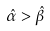<formula> <loc_0><loc_0><loc_500><loc_500>\hat { \alpha } > \hat { \beta }</formula> 